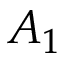<formula> <loc_0><loc_0><loc_500><loc_500>A _ { 1 }</formula> 